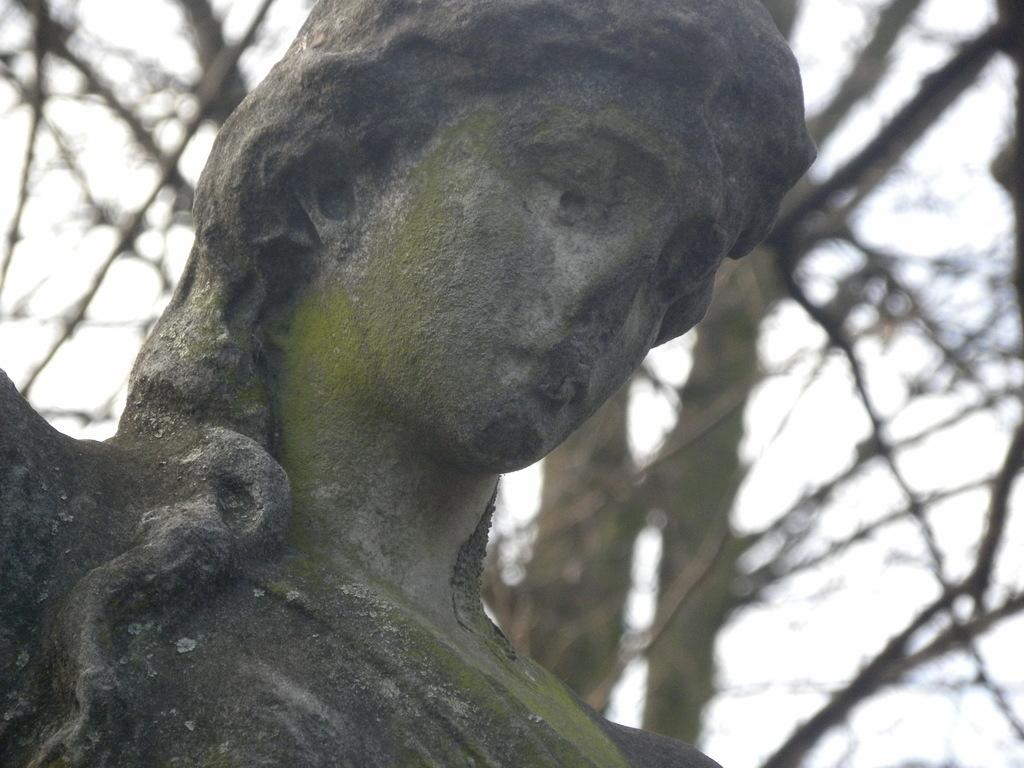What is the main subject in the image? There is a statue in the image. What can be seen in the background of the image? There are trees and the sky visible in the background of the image. How many trucks are parked near the statue in the image? There are no trucks present in the image; it only features a statue and the background elements. 